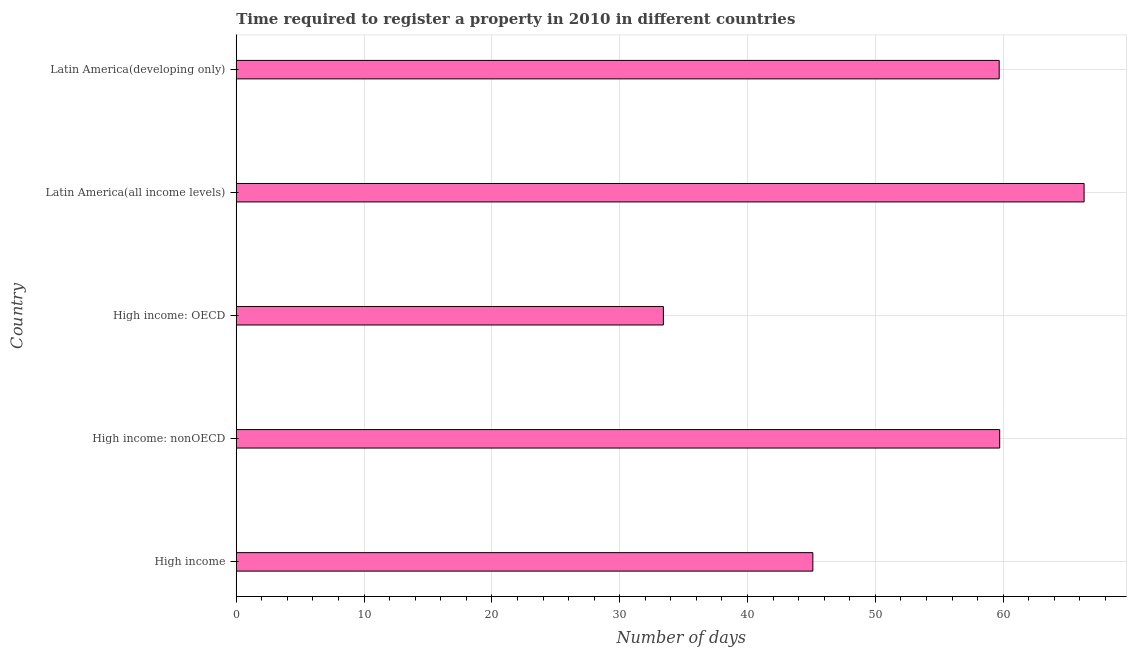What is the title of the graph?
Make the answer very short. Time required to register a property in 2010 in different countries. What is the label or title of the X-axis?
Provide a short and direct response. Number of days. What is the number of days required to register property in High income: OECD?
Keep it short and to the point. 33.42. Across all countries, what is the maximum number of days required to register property?
Make the answer very short. 66.33. Across all countries, what is the minimum number of days required to register property?
Provide a short and direct response. 33.42. In which country was the number of days required to register property maximum?
Provide a succinct answer. Latin America(all income levels). In which country was the number of days required to register property minimum?
Keep it short and to the point. High income: OECD. What is the sum of the number of days required to register property?
Your response must be concise. 264.28. What is the difference between the number of days required to register property in High income: nonOECD and Latin America(all income levels)?
Your answer should be very brief. -6.6. What is the average number of days required to register property per country?
Offer a very short reply. 52.86. What is the median number of days required to register property?
Your answer should be very brief. 59.69. What is the ratio of the number of days required to register property in High income to that in High income: OECD?
Offer a very short reply. 1.35. Is the difference between the number of days required to register property in High income: nonOECD and Latin America(all income levels) greater than the difference between any two countries?
Provide a succinct answer. No. What is the difference between the highest and the second highest number of days required to register property?
Your answer should be very brief. 6.6. What is the difference between the highest and the lowest number of days required to register property?
Offer a very short reply. 32.92. In how many countries, is the number of days required to register property greater than the average number of days required to register property taken over all countries?
Offer a terse response. 3. What is the difference between two consecutive major ticks on the X-axis?
Your response must be concise. 10. Are the values on the major ticks of X-axis written in scientific E-notation?
Provide a succinct answer. No. What is the Number of days in High income?
Your answer should be very brief. 45.11. What is the Number of days of High income: nonOECD?
Ensure brevity in your answer.  59.73. What is the Number of days in High income: OECD?
Your answer should be compact. 33.42. What is the Number of days of Latin America(all income levels)?
Your response must be concise. 66.33. What is the Number of days in Latin America(developing only)?
Make the answer very short. 59.69. What is the difference between the Number of days in High income and High income: nonOECD?
Your answer should be very brief. -14.62. What is the difference between the Number of days in High income and High income: OECD?
Keep it short and to the point. 11.69. What is the difference between the Number of days in High income and Latin America(all income levels)?
Keep it short and to the point. -21.22. What is the difference between the Number of days in High income and Latin America(developing only)?
Your answer should be very brief. -14.58. What is the difference between the Number of days in High income: nonOECD and High income: OECD?
Offer a terse response. 26.31. What is the difference between the Number of days in High income: nonOECD and Latin America(all income levels)?
Your answer should be compact. -6.6. What is the difference between the Number of days in High income: nonOECD and Latin America(developing only)?
Give a very brief answer. 0.04. What is the difference between the Number of days in High income: OECD and Latin America(all income levels)?
Provide a succinct answer. -32.92. What is the difference between the Number of days in High income: OECD and Latin America(developing only)?
Your answer should be very brief. -26.27. What is the difference between the Number of days in Latin America(all income levels) and Latin America(developing only)?
Give a very brief answer. 6.64. What is the ratio of the Number of days in High income to that in High income: nonOECD?
Give a very brief answer. 0.76. What is the ratio of the Number of days in High income to that in High income: OECD?
Provide a succinct answer. 1.35. What is the ratio of the Number of days in High income to that in Latin America(all income levels)?
Give a very brief answer. 0.68. What is the ratio of the Number of days in High income to that in Latin America(developing only)?
Offer a terse response. 0.76. What is the ratio of the Number of days in High income: nonOECD to that in High income: OECD?
Your answer should be compact. 1.79. What is the ratio of the Number of days in High income: nonOECD to that in Latin America(all income levels)?
Offer a very short reply. 0.9. What is the ratio of the Number of days in High income: OECD to that in Latin America(all income levels)?
Offer a very short reply. 0.5. What is the ratio of the Number of days in High income: OECD to that in Latin America(developing only)?
Make the answer very short. 0.56. What is the ratio of the Number of days in Latin America(all income levels) to that in Latin America(developing only)?
Your response must be concise. 1.11. 